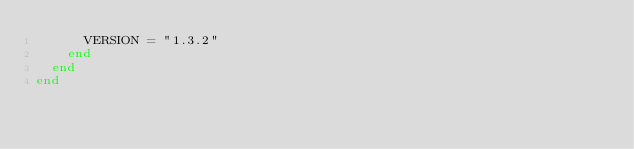<code> <loc_0><loc_0><loc_500><loc_500><_Ruby_>      VERSION = "1.3.2"
    end
  end
end
</code> 